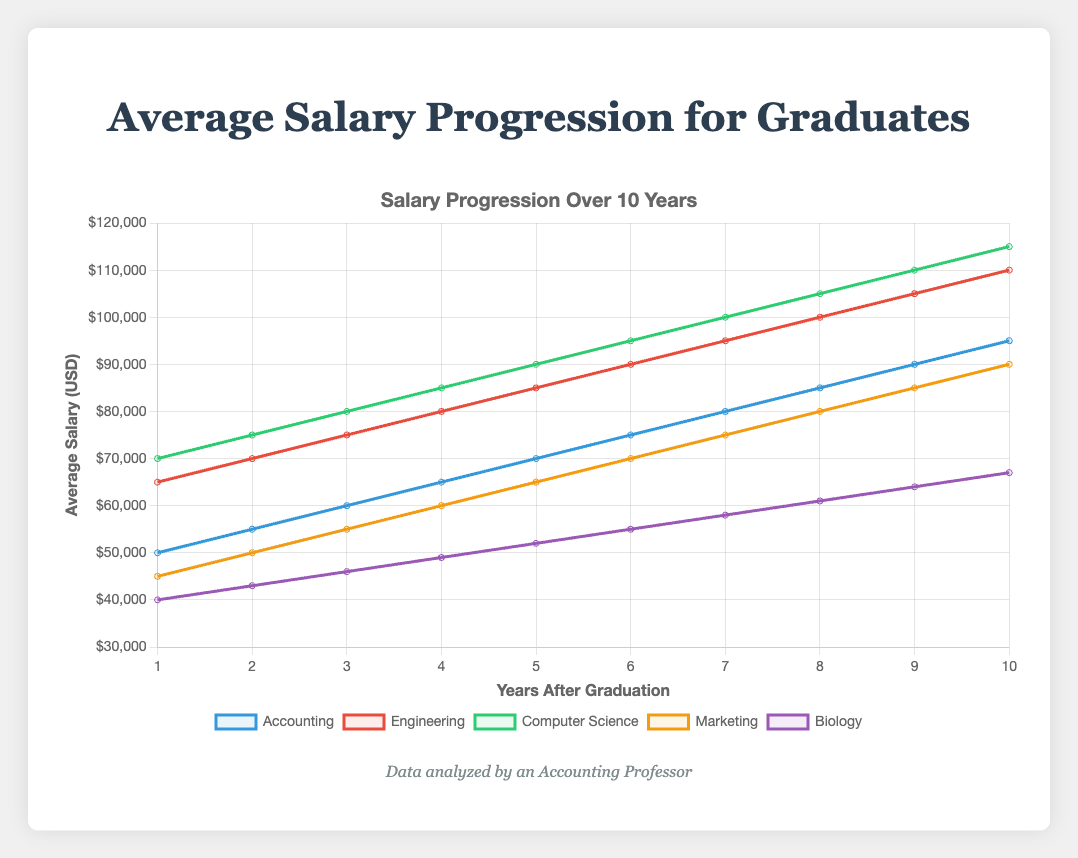How does the average salary progression for Accounting graduates compare to those of Computer Science graduates over the 10-year period? By observing the figure, we see that Computer Science graduates consistently earn more than Accounting graduates each year. For example, in Year 1, Computer Science graduates earn $70,000 whereas Accounting graduates earn $50,000. This trend continues with Computer Science graduates earning $115,000 in Year 10 compared to $95,000 for Accounting graduates.
Answer: Computer Science graduates have higher average salaries every year compared to Accounting graduates What is the difference in salary between Engineering and Biology graduates in the 5th year? From the figure, the salary for Engineering graduates in Year 5 is $85,000, and for Biology graduates, it is $52,000. The difference is calculated as $85,000 - $52,000.
Answer: $33,000 Which field has the slowest salary progression rate over the 10 years? The slope of the salary progression line for Biology is the flattest when compared to the other fields, indicating the slowest rate of salary increase over 10 years. Biology starts at $40,000 in Year 1 and ends at $67,000 in Year 10.
Answer: Biology What's the total sum of salaries after 10 years for Marketing graduates? Summing the salaries for Marketing graduates over the 10 years: $45,000 + $50,000 + $55,000 + $60,000 + $65,000 + $70,000 + $75,000 + $80,000 + $85,000 + $90,000. The total is $675,000.
Answer: $675,000 In which year do Accounting graduates exceed $70,000 in average salary? By examining the figure, Accounting graduates exceed $70,000 in Year 6, where the average salary is $75,000.
Answer: Year 6 What is the average salary for Computer Science graduates over the 10 years? Adding the salaries for each year for Computer Science graduates and dividing by 10: ($70,000 + $75,000 + $80,000 + $85,000 + $90,000 + $95,000 + $100,000 + $105,000 + $110,000 + $115,000) / 10 equals $92,500.
Answer: $92,500 By how much does the salary of Marketing graduates increase from Year 1 to Year 10? The salary for Marketing graduates in Year 1 is $45,000, and in Year 10, it is $90,000. The increase is calculated as $90,000 - $45,000.
Answer: $45,000 